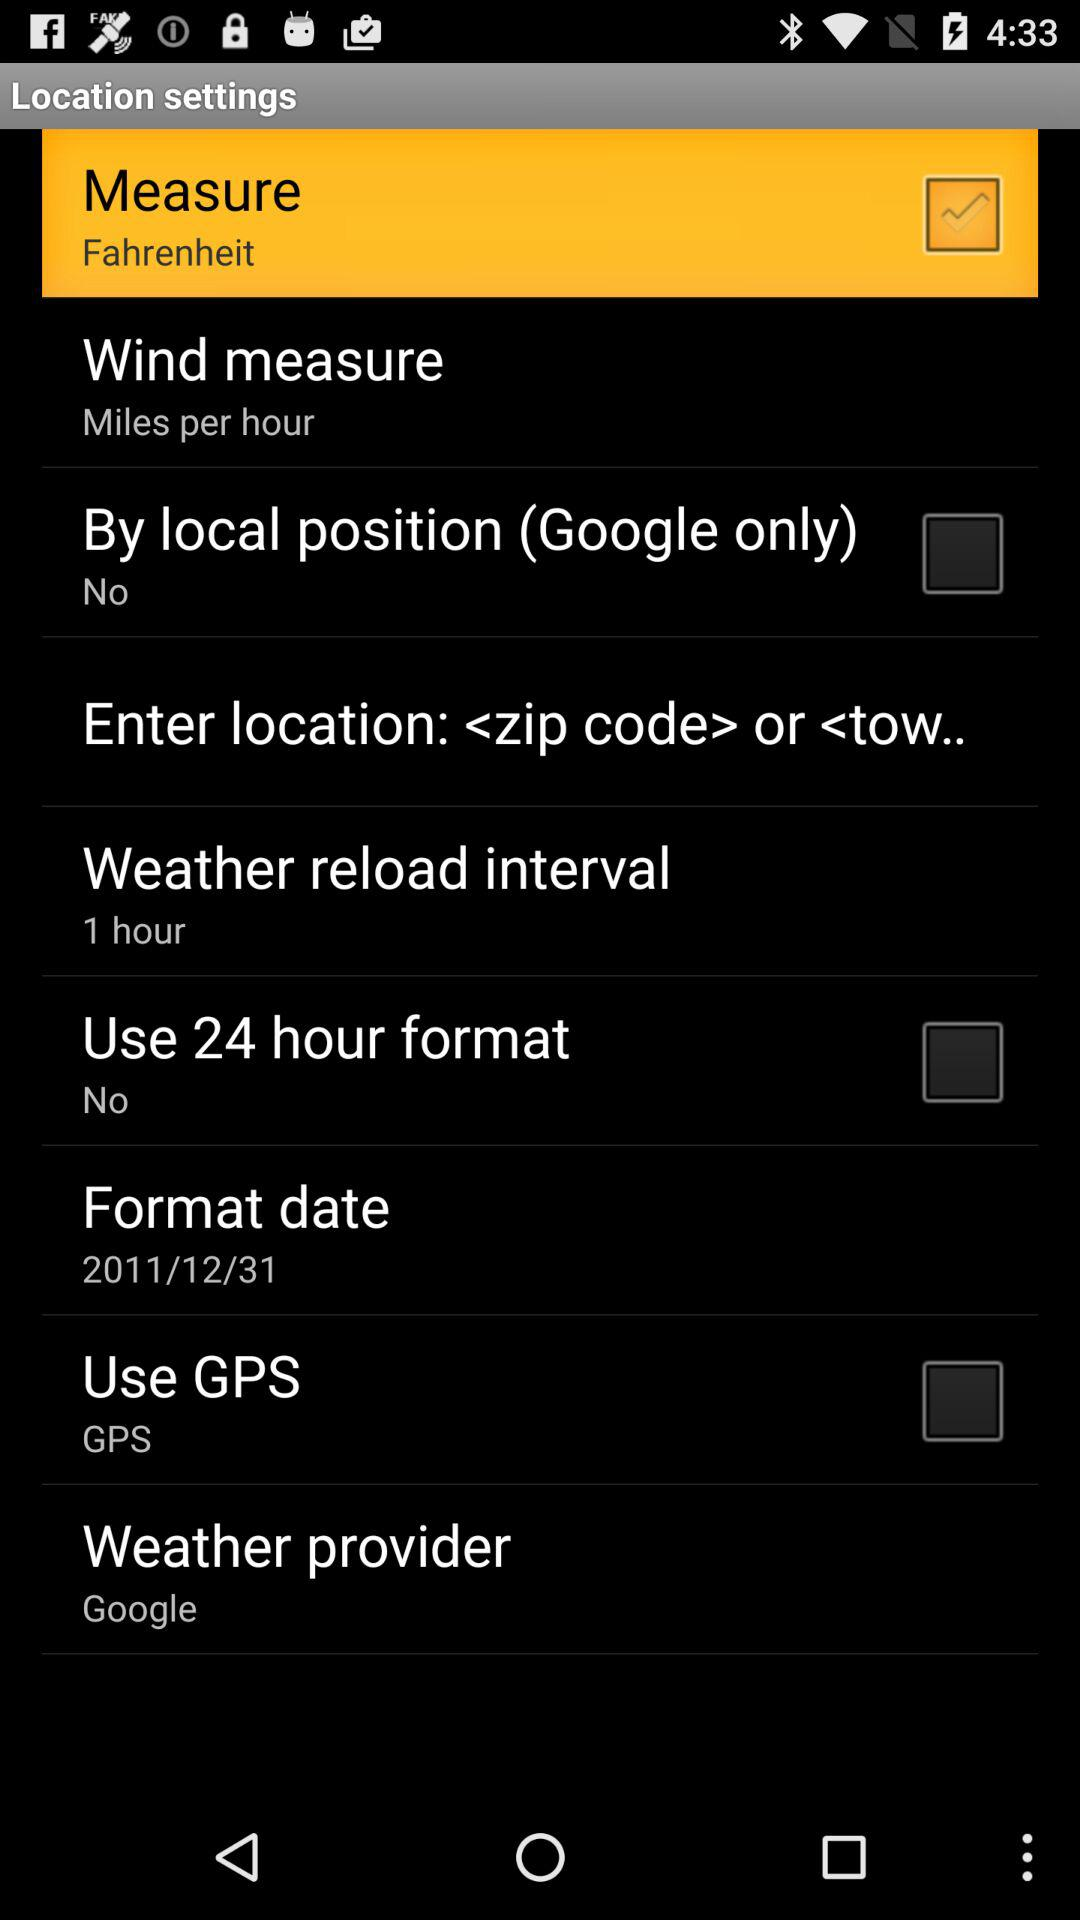How does wind get measured? Wind gets measured in miles per hour. 